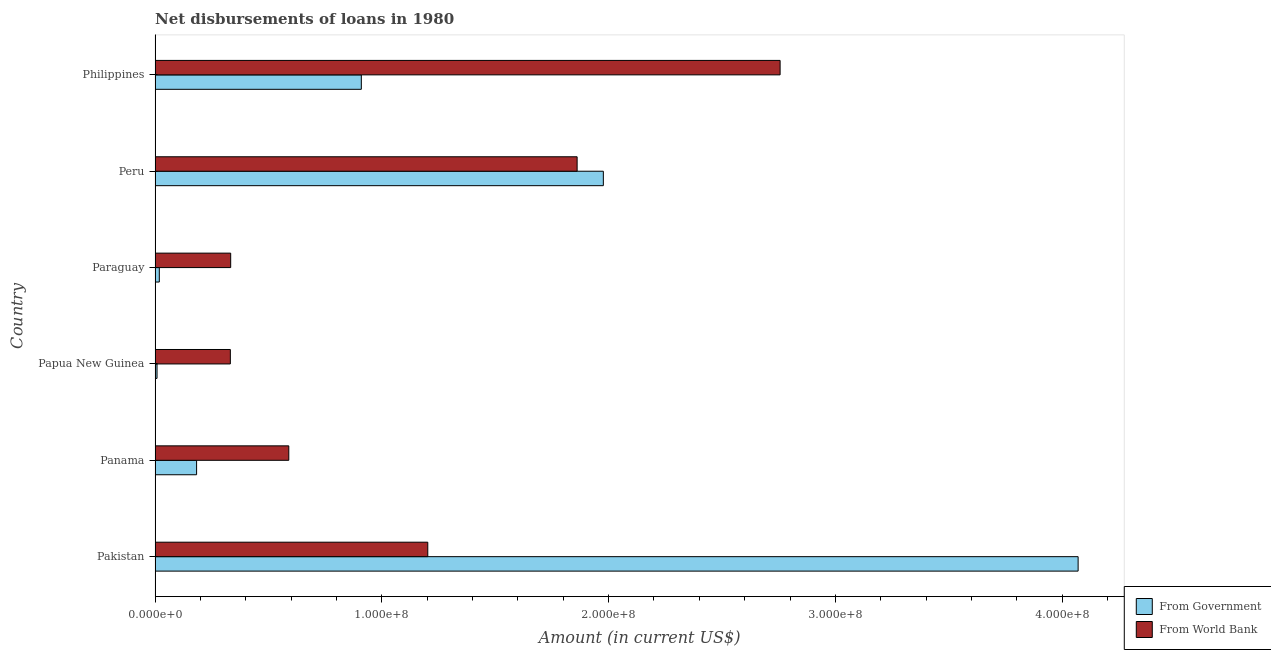How many groups of bars are there?
Your response must be concise. 6. Are the number of bars on each tick of the Y-axis equal?
Give a very brief answer. Yes. How many bars are there on the 3rd tick from the top?
Provide a succinct answer. 2. What is the net disbursements of loan from world bank in Pakistan?
Your response must be concise. 1.20e+08. Across all countries, what is the maximum net disbursements of loan from government?
Your answer should be compact. 4.07e+08. Across all countries, what is the minimum net disbursements of loan from world bank?
Your response must be concise. 3.32e+07. In which country was the net disbursements of loan from government minimum?
Make the answer very short. Papua New Guinea. What is the total net disbursements of loan from world bank in the graph?
Provide a succinct answer. 7.08e+08. What is the difference between the net disbursements of loan from government in Papua New Guinea and that in Paraguay?
Provide a short and direct response. -1.01e+06. What is the difference between the net disbursements of loan from government in Papua New Guinea and the net disbursements of loan from world bank in Peru?
Make the answer very short. -1.85e+08. What is the average net disbursements of loan from world bank per country?
Your response must be concise. 1.18e+08. What is the difference between the net disbursements of loan from world bank and net disbursements of loan from government in Peru?
Make the answer very short. -1.16e+07. What is the ratio of the net disbursements of loan from government in Pakistan to that in Paraguay?
Provide a succinct answer. 216.86. Is the net disbursements of loan from world bank in Paraguay less than that in Peru?
Ensure brevity in your answer.  Yes. Is the difference between the net disbursements of loan from world bank in Panama and Paraguay greater than the difference between the net disbursements of loan from government in Panama and Paraguay?
Your answer should be compact. Yes. What is the difference between the highest and the second highest net disbursements of loan from government?
Offer a very short reply. 2.09e+08. What is the difference between the highest and the lowest net disbursements of loan from government?
Provide a succinct answer. 4.06e+08. What does the 2nd bar from the top in Peru represents?
Provide a short and direct response. From Government. What does the 1st bar from the bottom in Peru represents?
Provide a succinct answer. From Government. How many bars are there?
Give a very brief answer. 12. Are all the bars in the graph horizontal?
Your answer should be compact. Yes. How many countries are there in the graph?
Make the answer very short. 6. Does the graph contain any zero values?
Give a very brief answer. No. Where does the legend appear in the graph?
Ensure brevity in your answer.  Bottom right. How are the legend labels stacked?
Offer a very short reply. Vertical. What is the title of the graph?
Ensure brevity in your answer.  Net disbursements of loans in 1980. Does "Primary" appear as one of the legend labels in the graph?
Your response must be concise. No. What is the Amount (in current US$) of From Government in Pakistan?
Provide a short and direct response. 4.07e+08. What is the Amount (in current US$) in From World Bank in Pakistan?
Your response must be concise. 1.20e+08. What is the Amount (in current US$) of From Government in Panama?
Provide a succinct answer. 1.83e+07. What is the Amount (in current US$) in From World Bank in Panama?
Provide a succinct answer. 5.90e+07. What is the Amount (in current US$) in From Government in Papua New Guinea?
Ensure brevity in your answer.  8.70e+05. What is the Amount (in current US$) of From World Bank in Papua New Guinea?
Offer a very short reply. 3.32e+07. What is the Amount (in current US$) in From Government in Paraguay?
Make the answer very short. 1.88e+06. What is the Amount (in current US$) of From World Bank in Paraguay?
Your response must be concise. 3.34e+07. What is the Amount (in current US$) in From Government in Peru?
Your answer should be very brief. 1.98e+08. What is the Amount (in current US$) of From World Bank in Peru?
Offer a very short reply. 1.86e+08. What is the Amount (in current US$) in From Government in Philippines?
Provide a short and direct response. 9.10e+07. What is the Amount (in current US$) of From World Bank in Philippines?
Ensure brevity in your answer.  2.76e+08. Across all countries, what is the maximum Amount (in current US$) of From Government?
Ensure brevity in your answer.  4.07e+08. Across all countries, what is the maximum Amount (in current US$) of From World Bank?
Keep it short and to the point. 2.76e+08. Across all countries, what is the minimum Amount (in current US$) in From Government?
Your response must be concise. 8.70e+05. Across all countries, what is the minimum Amount (in current US$) in From World Bank?
Your answer should be compact. 3.32e+07. What is the total Amount (in current US$) in From Government in the graph?
Make the answer very short. 7.17e+08. What is the total Amount (in current US$) of From World Bank in the graph?
Give a very brief answer. 7.08e+08. What is the difference between the Amount (in current US$) of From Government in Pakistan and that in Panama?
Give a very brief answer. 3.89e+08. What is the difference between the Amount (in current US$) in From World Bank in Pakistan and that in Panama?
Make the answer very short. 6.13e+07. What is the difference between the Amount (in current US$) in From Government in Pakistan and that in Papua New Guinea?
Your answer should be very brief. 4.06e+08. What is the difference between the Amount (in current US$) in From World Bank in Pakistan and that in Papua New Guinea?
Keep it short and to the point. 8.71e+07. What is the difference between the Amount (in current US$) of From Government in Pakistan and that in Paraguay?
Make the answer very short. 4.05e+08. What is the difference between the Amount (in current US$) of From World Bank in Pakistan and that in Paraguay?
Your response must be concise. 8.69e+07. What is the difference between the Amount (in current US$) of From Government in Pakistan and that in Peru?
Your answer should be very brief. 2.09e+08. What is the difference between the Amount (in current US$) in From World Bank in Pakistan and that in Peru?
Your answer should be very brief. -6.59e+07. What is the difference between the Amount (in current US$) of From Government in Pakistan and that in Philippines?
Your response must be concise. 3.16e+08. What is the difference between the Amount (in current US$) of From World Bank in Pakistan and that in Philippines?
Offer a very short reply. -1.55e+08. What is the difference between the Amount (in current US$) of From Government in Panama and that in Papua New Guinea?
Provide a short and direct response. 1.74e+07. What is the difference between the Amount (in current US$) of From World Bank in Panama and that in Papua New Guinea?
Your answer should be compact. 2.58e+07. What is the difference between the Amount (in current US$) in From Government in Panama and that in Paraguay?
Your answer should be compact. 1.64e+07. What is the difference between the Amount (in current US$) in From World Bank in Panama and that in Paraguay?
Your answer should be compact. 2.56e+07. What is the difference between the Amount (in current US$) of From Government in Panama and that in Peru?
Provide a succinct answer. -1.79e+08. What is the difference between the Amount (in current US$) in From World Bank in Panama and that in Peru?
Provide a short and direct response. -1.27e+08. What is the difference between the Amount (in current US$) in From Government in Panama and that in Philippines?
Make the answer very short. -7.26e+07. What is the difference between the Amount (in current US$) in From World Bank in Panama and that in Philippines?
Your answer should be very brief. -2.17e+08. What is the difference between the Amount (in current US$) of From Government in Papua New Guinea and that in Paraguay?
Offer a terse response. -1.01e+06. What is the difference between the Amount (in current US$) of From World Bank in Papua New Guinea and that in Paraguay?
Offer a terse response. -1.52e+05. What is the difference between the Amount (in current US$) in From Government in Papua New Guinea and that in Peru?
Keep it short and to the point. -1.97e+08. What is the difference between the Amount (in current US$) in From World Bank in Papua New Guinea and that in Peru?
Ensure brevity in your answer.  -1.53e+08. What is the difference between the Amount (in current US$) in From Government in Papua New Guinea and that in Philippines?
Offer a terse response. -9.01e+07. What is the difference between the Amount (in current US$) in From World Bank in Papua New Guinea and that in Philippines?
Provide a succinct answer. -2.42e+08. What is the difference between the Amount (in current US$) of From Government in Paraguay and that in Peru?
Offer a terse response. -1.96e+08. What is the difference between the Amount (in current US$) of From World Bank in Paraguay and that in Peru?
Make the answer very short. -1.53e+08. What is the difference between the Amount (in current US$) in From Government in Paraguay and that in Philippines?
Keep it short and to the point. -8.91e+07. What is the difference between the Amount (in current US$) in From World Bank in Paraguay and that in Philippines?
Provide a short and direct response. -2.42e+08. What is the difference between the Amount (in current US$) in From Government in Peru and that in Philippines?
Provide a short and direct response. 1.07e+08. What is the difference between the Amount (in current US$) of From World Bank in Peru and that in Philippines?
Ensure brevity in your answer.  -8.95e+07. What is the difference between the Amount (in current US$) in From Government in Pakistan and the Amount (in current US$) in From World Bank in Panama?
Give a very brief answer. 3.48e+08. What is the difference between the Amount (in current US$) of From Government in Pakistan and the Amount (in current US$) of From World Bank in Papua New Guinea?
Provide a short and direct response. 3.74e+08. What is the difference between the Amount (in current US$) of From Government in Pakistan and the Amount (in current US$) of From World Bank in Paraguay?
Your answer should be compact. 3.74e+08. What is the difference between the Amount (in current US$) in From Government in Pakistan and the Amount (in current US$) in From World Bank in Peru?
Offer a very short reply. 2.21e+08. What is the difference between the Amount (in current US$) of From Government in Pakistan and the Amount (in current US$) of From World Bank in Philippines?
Your response must be concise. 1.31e+08. What is the difference between the Amount (in current US$) in From Government in Panama and the Amount (in current US$) in From World Bank in Papua New Guinea?
Offer a terse response. -1.49e+07. What is the difference between the Amount (in current US$) of From Government in Panama and the Amount (in current US$) of From World Bank in Paraguay?
Ensure brevity in your answer.  -1.50e+07. What is the difference between the Amount (in current US$) in From Government in Panama and the Amount (in current US$) in From World Bank in Peru?
Your response must be concise. -1.68e+08. What is the difference between the Amount (in current US$) in From Government in Panama and the Amount (in current US$) in From World Bank in Philippines?
Offer a very short reply. -2.57e+08. What is the difference between the Amount (in current US$) of From Government in Papua New Guinea and the Amount (in current US$) of From World Bank in Paraguay?
Give a very brief answer. -3.25e+07. What is the difference between the Amount (in current US$) in From Government in Papua New Guinea and the Amount (in current US$) in From World Bank in Peru?
Offer a very short reply. -1.85e+08. What is the difference between the Amount (in current US$) of From Government in Papua New Guinea and the Amount (in current US$) of From World Bank in Philippines?
Your answer should be very brief. -2.75e+08. What is the difference between the Amount (in current US$) in From Government in Paraguay and the Amount (in current US$) in From World Bank in Peru?
Make the answer very short. -1.84e+08. What is the difference between the Amount (in current US$) of From Government in Paraguay and the Amount (in current US$) of From World Bank in Philippines?
Provide a short and direct response. -2.74e+08. What is the difference between the Amount (in current US$) in From Government in Peru and the Amount (in current US$) in From World Bank in Philippines?
Offer a terse response. -7.80e+07. What is the average Amount (in current US$) in From Government per country?
Give a very brief answer. 1.19e+08. What is the average Amount (in current US$) of From World Bank per country?
Your answer should be compact. 1.18e+08. What is the difference between the Amount (in current US$) of From Government and Amount (in current US$) of From World Bank in Pakistan?
Your answer should be compact. 2.87e+08. What is the difference between the Amount (in current US$) of From Government and Amount (in current US$) of From World Bank in Panama?
Your answer should be compact. -4.07e+07. What is the difference between the Amount (in current US$) of From Government and Amount (in current US$) of From World Bank in Papua New Guinea?
Make the answer very short. -3.23e+07. What is the difference between the Amount (in current US$) of From Government and Amount (in current US$) of From World Bank in Paraguay?
Your answer should be compact. -3.15e+07. What is the difference between the Amount (in current US$) of From Government and Amount (in current US$) of From World Bank in Peru?
Provide a succinct answer. 1.16e+07. What is the difference between the Amount (in current US$) in From Government and Amount (in current US$) in From World Bank in Philippines?
Give a very brief answer. -1.85e+08. What is the ratio of the Amount (in current US$) in From Government in Pakistan to that in Panama?
Offer a very short reply. 22.22. What is the ratio of the Amount (in current US$) in From World Bank in Pakistan to that in Panama?
Offer a terse response. 2.04. What is the ratio of the Amount (in current US$) in From Government in Pakistan to that in Papua New Guinea?
Provide a succinct answer. 467.87. What is the ratio of the Amount (in current US$) in From World Bank in Pakistan to that in Papua New Guinea?
Your response must be concise. 3.62. What is the ratio of the Amount (in current US$) of From Government in Pakistan to that in Paraguay?
Give a very brief answer. 216.86. What is the ratio of the Amount (in current US$) of From World Bank in Pakistan to that in Paraguay?
Make the answer very short. 3.61. What is the ratio of the Amount (in current US$) of From Government in Pakistan to that in Peru?
Your answer should be very brief. 2.06. What is the ratio of the Amount (in current US$) in From World Bank in Pakistan to that in Peru?
Your answer should be compact. 0.65. What is the ratio of the Amount (in current US$) of From Government in Pakistan to that in Philippines?
Your answer should be compact. 4.47. What is the ratio of the Amount (in current US$) in From World Bank in Pakistan to that in Philippines?
Your answer should be very brief. 0.44. What is the ratio of the Amount (in current US$) in From Government in Panama to that in Papua New Guinea?
Offer a very short reply. 21.05. What is the ratio of the Amount (in current US$) of From World Bank in Panama to that in Papua New Guinea?
Offer a very short reply. 1.78. What is the ratio of the Amount (in current US$) in From Government in Panama to that in Paraguay?
Your answer should be compact. 9.76. What is the ratio of the Amount (in current US$) of From World Bank in Panama to that in Paraguay?
Your answer should be very brief. 1.77. What is the ratio of the Amount (in current US$) of From Government in Panama to that in Peru?
Offer a very short reply. 0.09. What is the ratio of the Amount (in current US$) of From World Bank in Panama to that in Peru?
Your answer should be compact. 0.32. What is the ratio of the Amount (in current US$) of From Government in Panama to that in Philippines?
Offer a terse response. 0.2. What is the ratio of the Amount (in current US$) of From World Bank in Panama to that in Philippines?
Your answer should be very brief. 0.21. What is the ratio of the Amount (in current US$) in From Government in Papua New Guinea to that in Paraguay?
Give a very brief answer. 0.46. What is the ratio of the Amount (in current US$) of From Government in Papua New Guinea to that in Peru?
Offer a very short reply. 0. What is the ratio of the Amount (in current US$) in From World Bank in Papua New Guinea to that in Peru?
Keep it short and to the point. 0.18. What is the ratio of the Amount (in current US$) in From Government in Papua New Guinea to that in Philippines?
Keep it short and to the point. 0.01. What is the ratio of the Amount (in current US$) of From World Bank in Papua New Guinea to that in Philippines?
Your answer should be compact. 0.12. What is the ratio of the Amount (in current US$) of From Government in Paraguay to that in Peru?
Offer a very short reply. 0.01. What is the ratio of the Amount (in current US$) of From World Bank in Paraguay to that in Peru?
Offer a very short reply. 0.18. What is the ratio of the Amount (in current US$) of From Government in Paraguay to that in Philippines?
Your answer should be very brief. 0.02. What is the ratio of the Amount (in current US$) in From World Bank in Paraguay to that in Philippines?
Provide a succinct answer. 0.12. What is the ratio of the Amount (in current US$) of From Government in Peru to that in Philippines?
Provide a succinct answer. 2.17. What is the ratio of the Amount (in current US$) in From World Bank in Peru to that in Philippines?
Keep it short and to the point. 0.68. What is the difference between the highest and the second highest Amount (in current US$) in From Government?
Your answer should be compact. 2.09e+08. What is the difference between the highest and the second highest Amount (in current US$) in From World Bank?
Give a very brief answer. 8.95e+07. What is the difference between the highest and the lowest Amount (in current US$) of From Government?
Your answer should be compact. 4.06e+08. What is the difference between the highest and the lowest Amount (in current US$) of From World Bank?
Your answer should be compact. 2.42e+08. 